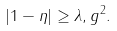Convert formula to latex. <formula><loc_0><loc_0><loc_500><loc_500>| 1 - \eta | \geq \lambda , g ^ { 2 } .</formula> 